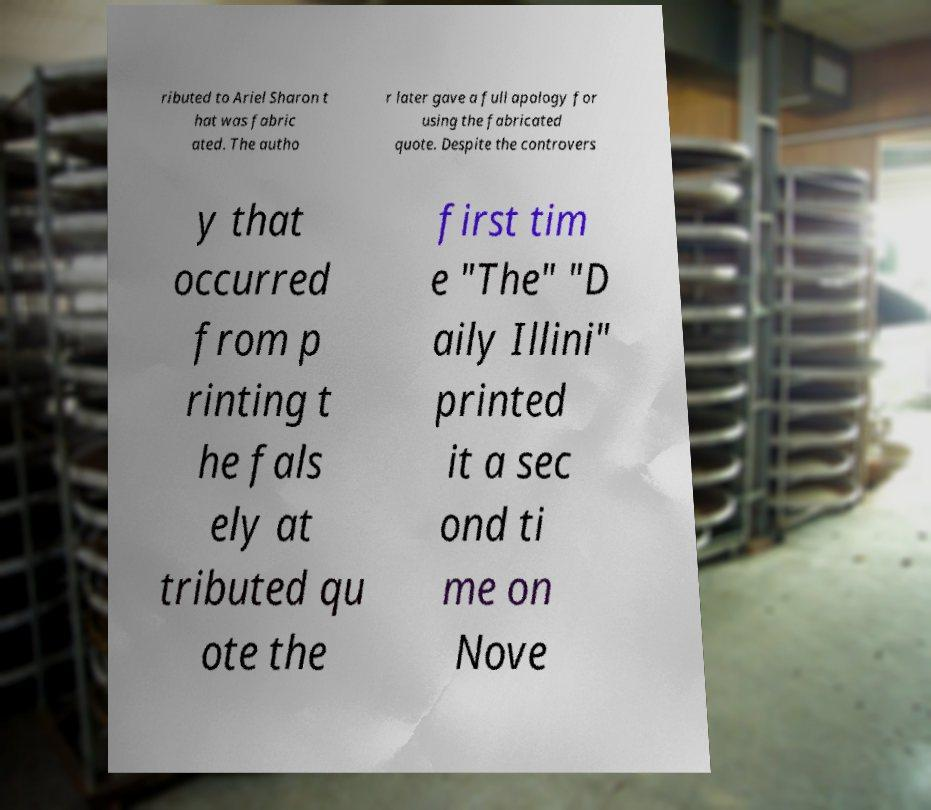For documentation purposes, I need the text within this image transcribed. Could you provide that? ributed to Ariel Sharon t hat was fabric ated. The autho r later gave a full apology for using the fabricated quote. Despite the controvers y that occurred from p rinting t he fals ely at tributed qu ote the first tim e "The" "D aily Illini" printed it a sec ond ti me on Nove 